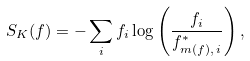Convert formula to latex. <formula><loc_0><loc_0><loc_500><loc_500>S _ { K } ( f ) = - \sum _ { i } f _ { i } \log \left ( \frac { f _ { i } } { f ^ { * } _ { m ( f ) , \, i } } \right ) ,</formula> 